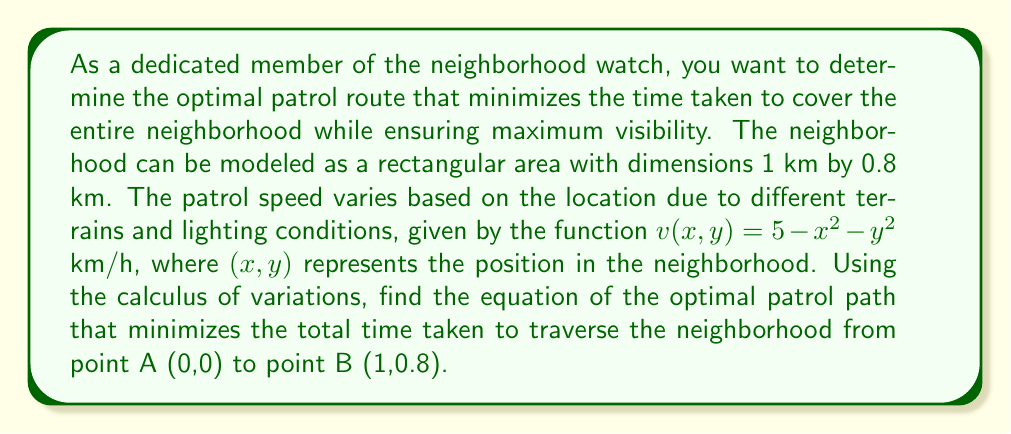Teach me how to tackle this problem. To solve this problem, we'll use the Euler-Lagrange equation from the calculus of variations. Let's approach this step-by-step:

1) The time taken to travel an infinitesimal distance $ds$ is given by $dt = \frac{ds}{v}$. We need to minimize the total time:

   $$T = \int_0^1 \frac{ds}{v(x,y)} = \int_0^1 \frac{\sqrt{1 + (y')^2}}{5 - x^2 - y^2} dx$$

2) Let's define our functional:

   $$F(x, y, y') = \frac{\sqrt{1 + (y')^2}}{5 - x^2 - y^2}$$

3) The Euler-Lagrange equation is:

   $$\frac{\partial F}{\partial y} - \frac{d}{dx}\left(\frac{\partial F}{\partial y'}\right) = 0$$

4) Let's calculate the partial derivatives:

   $$\frac{\partial F}{\partial y} = \frac{2y\sqrt{1 + (y')^2}}{(5 - x^2 - y^2)^2}$$

   $$\frac{\partial F}{\partial y'} = \frac{y'}{(5 - x^2 - y^2)\sqrt{1 + (y')^2}}$$

5) Now, we need to calculate $\frac{d}{dx}\left(\frac{\partial F}{\partial y'}\right)$. This is a complex expression, so let's simplify it by setting:

   $$\frac{y'}{(5 - x^2 - y^2)\sqrt{1 + (y')^2}} = C$$

   where C is a constant.

6) Rearranging this equation:

   $$(y')^2(5 - x^2 - y^2)^2 = C^2(1 + (y')^2)$$

7) Simplifying:

   $$y' = \pm \frac{C}{\sqrt{(5 - x^2 - y^2)^2 - C^2}}$$

8) This is the differential equation of the optimal path. The ± indicates that the path can curve upward or downward.

9) To find C, we can use the boundary conditions: y(0) = 0 and y(1) = 0.8. However, solving this explicitly is extremely complex and typically requires numerical methods.
Answer: The equation of the optimal patrol path is given by:

$$y' = \pm \frac{C}{\sqrt{(5 - x^2 - y^2)^2 - C^2}}$$

where C is a constant determined by the boundary conditions y(0) = 0 and y(1) = 0.8. The exact value of C and the explicit function y(x) would require numerical solving. 